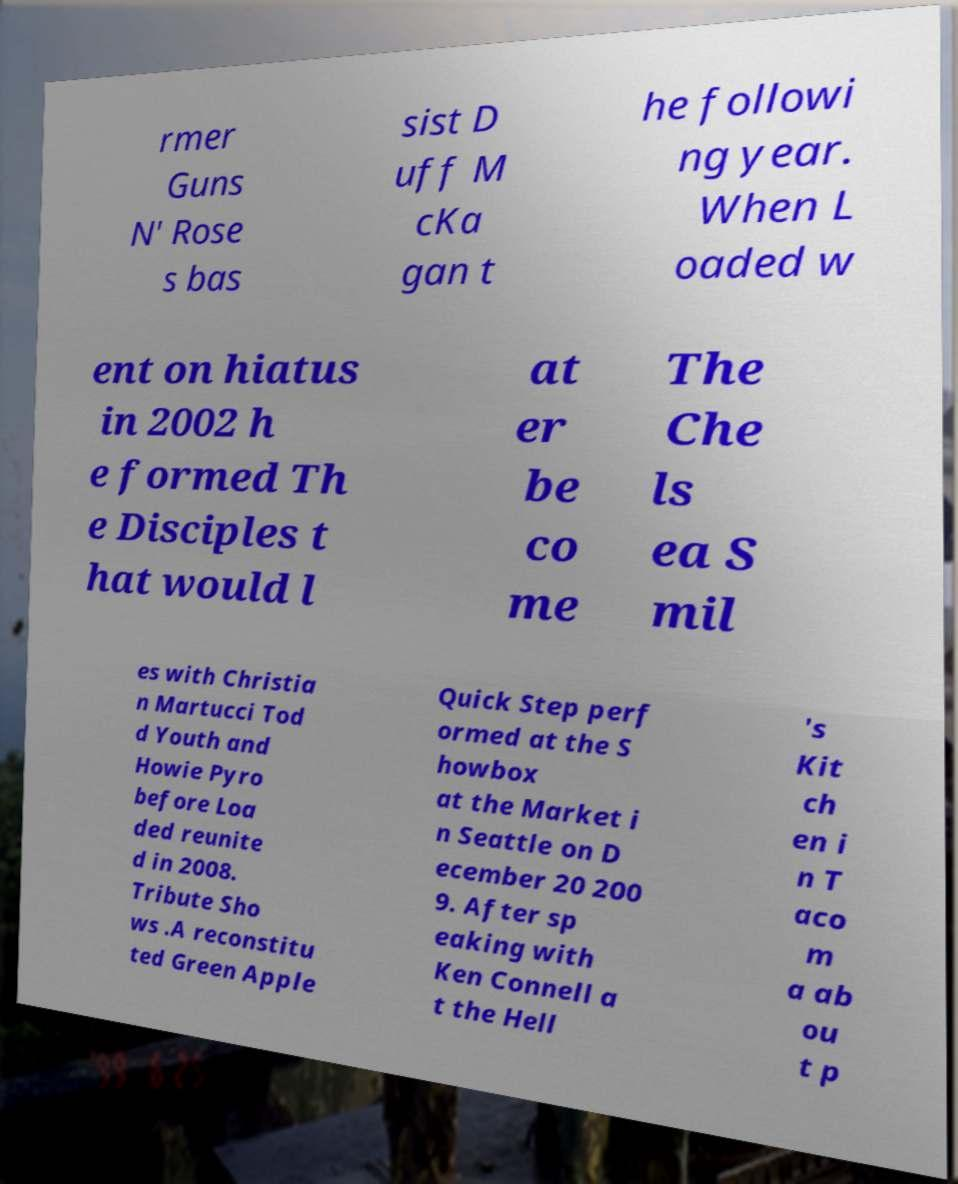There's text embedded in this image that I need extracted. Can you transcribe it verbatim? rmer Guns N' Rose s bas sist D uff M cKa gan t he followi ng year. When L oaded w ent on hiatus in 2002 h e formed Th e Disciples t hat would l at er be co me The Che ls ea S mil es with Christia n Martucci Tod d Youth and Howie Pyro before Loa ded reunite d in 2008. Tribute Sho ws .A reconstitu ted Green Apple Quick Step perf ormed at the S howbox at the Market i n Seattle on D ecember 20 200 9. After sp eaking with Ken Connell a t the Hell 's Kit ch en i n T aco m a ab ou t p 